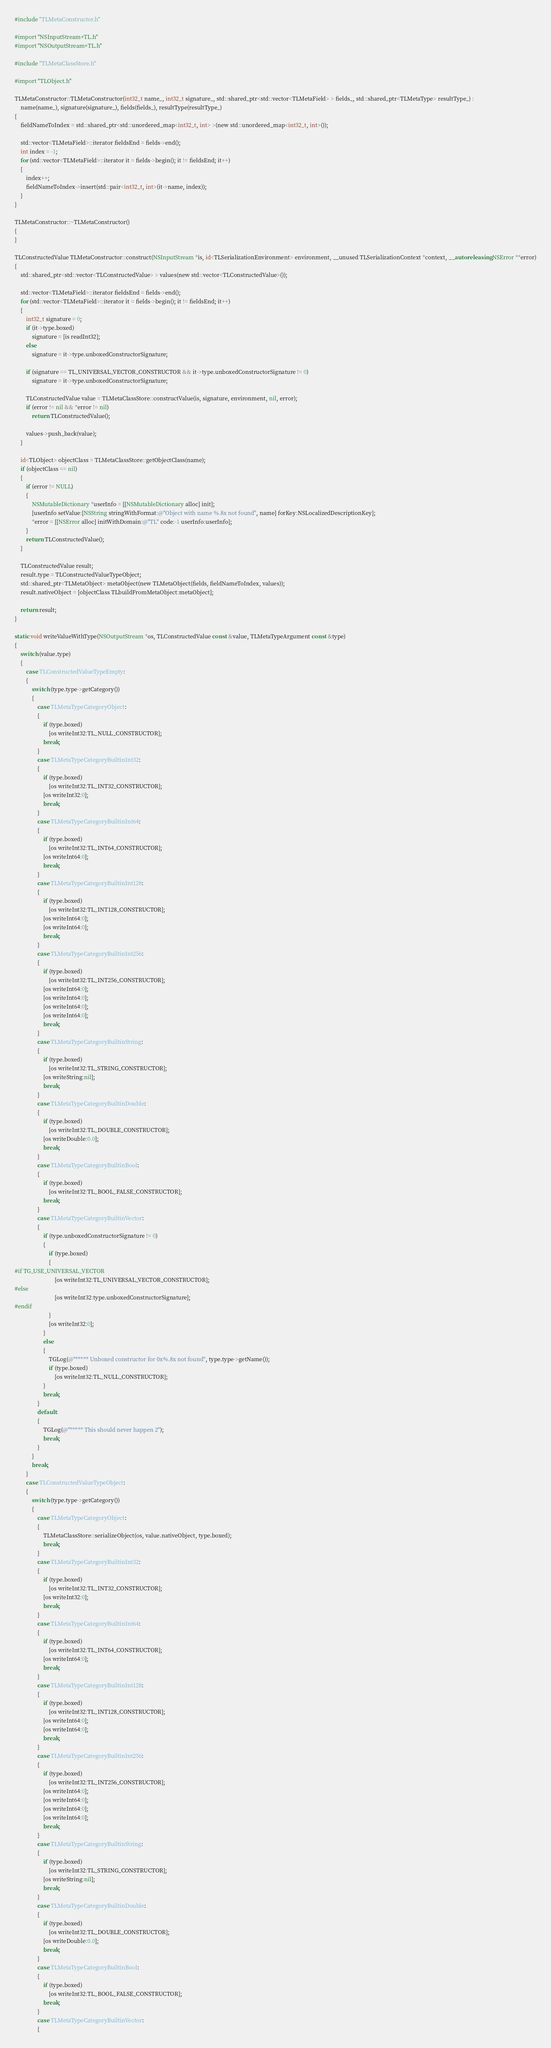Convert code to text. <code><loc_0><loc_0><loc_500><loc_500><_ObjectiveC_>#include "TLMetaConstructor.h"

#import "NSInputStream+TL.h"
#import "NSOutputStream+TL.h"

#include "TLMetaClassStore.h"

#import "TLObject.h"

TLMetaConstructor::TLMetaConstructor(int32_t name_, int32_t signature_, std::shared_ptr<std::vector<TLMetaField> > fields_, std::shared_ptr<TLMetaType> resultType_) :
    name(name_), signature(signature_), fields(fields_), resultType(resultType_)
{
    fieldNameToIndex = std::shared_ptr<std::unordered_map<int32_t, int> >(new std::unordered_map<int32_t, int>());
    
    std::vector<TLMetaField>::iterator fieldsEnd = fields->end();
    int index = -1;
    for (std::vector<TLMetaField>::iterator it = fields->begin(); it != fieldsEnd; it++)
    {
        index++;
        fieldNameToIndex->insert(std::pair<int32_t, int>(it->name, index));
    }
}

TLMetaConstructor::~TLMetaConstructor()
{
}

TLConstructedValue TLMetaConstructor::construct(NSInputStream *is, id<TLSerializationEnvironment> environment, __unused TLSerializationContext *context, __autoreleasing NSError **error)
{
    std::shared_ptr<std::vector<TLConstructedValue> > values(new std::vector<TLConstructedValue>());
    
    std::vector<TLMetaField>::iterator fieldsEnd = fields->end();
    for (std::vector<TLMetaField>::iterator it = fields->begin(); it != fieldsEnd; it++)
    {
        int32_t signature = 0;
        if (it->type.boxed)
            signature = [is readInt32];
        else
            signature = it->type.unboxedConstructorSignature;
        
        if (signature == TL_UNIVERSAL_VECTOR_CONSTRUCTOR && it->type.unboxedConstructorSignature != 0)
            signature = it->type.unboxedConstructorSignature;
        
        TLConstructedValue value = TLMetaClassStore::constructValue(is, signature, environment, nil, error);
        if (error != nil && *error != nil)
            return TLConstructedValue();
        
        values->push_back(value);
    }
    
    id<TLObject> objectClass = TLMetaClassStore::getObjectClass(name);
    if (objectClass == nil)
    {
        if (error != NULL)
        {
            NSMutableDictionary *userInfo = [[NSMutableDictionary alloc] init];
            [userInfo setValue:[NSString stringWithFormat:@"Object with name %.8x not found", name] forKey:NSLocalizedDescriptionKey];
            *error = [[NSError alloc] initWithDomain:@"TL" code:-1 userInfo:userInfo];
        }
        return TLConstructedValue();
    }
    
    TLConstructedValue result;
    result.type = TLConstructedValueTypeObject;
    std::shared_ptr<TLMetaObject> metaObject(new TLMetaObject(fields, fieldNameToIndex, values));
    result.nativeObject = [objectClass TLbuildFromMetaObject:metaObject];
    
    return result;
}

static void writeValueWithType(NSOutputStream *os, TLConstructedValue const &value, TLMetaTypeArgument const &type)
{   
    switch (value.type)
    {
        case TLConstructedValueTypeEmpty:
        {
            switch (type.type->getCategory())
            {
                case TLMetaTypeCategoryObject:
                {
                    if (type.boxed)
                        [os writeInt32:TL_NULL_CONSTRUCTOR];
                    break;
                }
                case TLMetaTypeCategoryBuiltinInt32:
                {
                    if (type.boxed)
                        [os writeInt32:TL_INT32_CONSTRUCTOR];
                    [os writeInt32:0];
                    break;
                }
                case TLMetaTypeCategoryBuiltinInt64:
                {
                    if (type.boxed)
                        [os writeInt32:TL_INT64_CONSTRUCTOR];
                    [os writeInt64:0];
                    break;
                }
                case TLMetaTypeCategoryBuiltinInt128:
                {
                    if (type.boxed)
                        [os writeInt32:TL_INT128_CONSTRUCTOR];
                    [os writeInt64:0];
                    [os writeInt64:0];
                    break;
                }
                case TLMetaTypeCategoryBuiltinInt256:
                {
                    if (type.boxed)
                        [os writeInt32:TL_INT256_CONSTRUCTOR];
                    [os writeInt64:0];
                    [os writeInt64:0];
                    [os writeInt64:0];
                    [os writeInt64:0];
                    break;
                }
                case TLMetaTypeCategoryBuiltinString:
                {
                    if (type.boxed)
                        [os writeInt32:TL_STRING_CONSTRUCTOR];
                    [os writeString:nil];
                    break;
                }
                case TLMetaTypeCategoryBuiltinDouble:
                {
                    if (type.boxed)
                        [os writeInt32:TL_DOUBLE_CONSTRUCTOR];
                    [os writeDouble:0.0];
                    break;
                }
                case TLMetaTypeCategoryBuiltinBool:
                {
                    if (type.boxed)
                        [os writeInt32:TL_BOOL_FALSE_CONSTRUCTOR];
                    break;
                }
                case TLMetaTypeCategoryBuiltinVector:
                {
                    if (type.unboxedConstructorSignature != 0)
                    {
                        if (type.boxed)
                        {
#if TG_USE_UNIVERSAL_VECTOR
                            [os writeInt32:TL_UNIVERSAL_VECTOR_CONSTRUCTOR];
#else
                            [os writeInt32:type.unboxedConstructorSignature];
#endif
                        }
                        [os writeInt32:0];
                    }
                    else
                    {
                        TGLog(@"***** Unboxed constructor for 0x%.8x not found", type.type->getName());
                        if (type.boxed)
                            [os writeInt32:TL_NULL_CONSTRUCTOR];
                    }
                    break;
                }
                default:
                {
                    TGLog(@"***** This should never happen 2");
                    break;
                }
            }
            break;
        }
        case TLConstructedValueTypeObject:
        {
            switch (type.type->getCategory())
            {
                case TLMetaTypeCategoryObject:
                {
                    TLMetaClassStore::serializeObject(os, value.nativeObject, type.boxed);
                    break;
                }
                case TLMetaTypeCategoryBuiltinInt32:
                {
                    if (type.boxed)
                        [os writeInt32:TL_INT32_CONSTRUCTOR];
                    [os writeInt32:0];
                    break;
                }
                case TLMetaTypeCategoryBuiltinInt64:
                {
                    if (type.boxed)
                        [os writeInt32:TL_INT64_CONSTRUCTOR];
                    [os writeInt64:0];
                    break;
                }
                case TLMetaTypeCategoryBuiltinInt128:
                {
                    if (type.boxed)
                        [os writeInt32:TL_INT128_CONSTRUCTOR];
                    [os writeInt64:0];
                    [os writeInt64:0];
                    break;
                }
                case TLMetaTypeCategoryBuiltinInt256:
                {
                    if (type.boxed)
                        [os writeInt32:TL_INT256_CONSTRUCTOR];
                    [os writeInt64:0];
                    [os writeInt64:0];
                    [os writeInt64:0];
                    [os writeInt64:0];
                    break;
                }
                case TLMetaTypeCategoryBuiltinString:
                {
                    if (type.boxed)
                        [os writeInt32:TL_STRING_CONSTRUCTOR];
                    [os writeString:nil];
                    break;
                }
                case TLMetaTypeCategoryBuiltinDouble:
                {
                    if (type.boxed)
                        [os writeInt32:TL_DOUBLE_CONSTRUCTOR];
                    [os writeDouble:0.0];
                    break;
                }
                case TLMetaTypeCategoryBuiltinBool:
                {
                    if (type.boxed)
                        [os writeInt32:TL_BOOL_FALSE_CONSTRUCTOR];
                    break;
                }
                case TLMetaTypeCategoryBuiltinVector:
                {</code> 